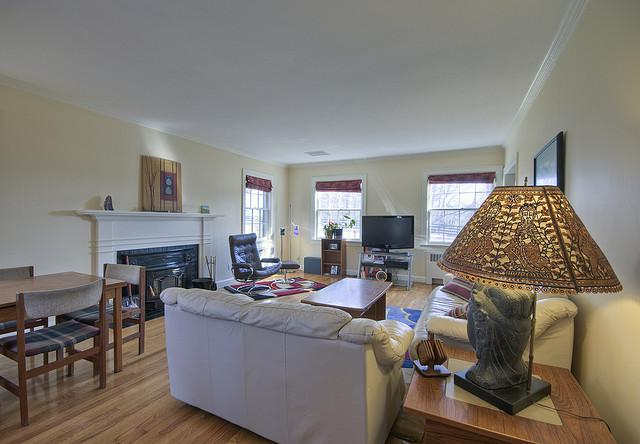What color are the sofa seats surrounding the table on the rug?

Choices:
A) red
B) green
C) blue
D) cream cream 